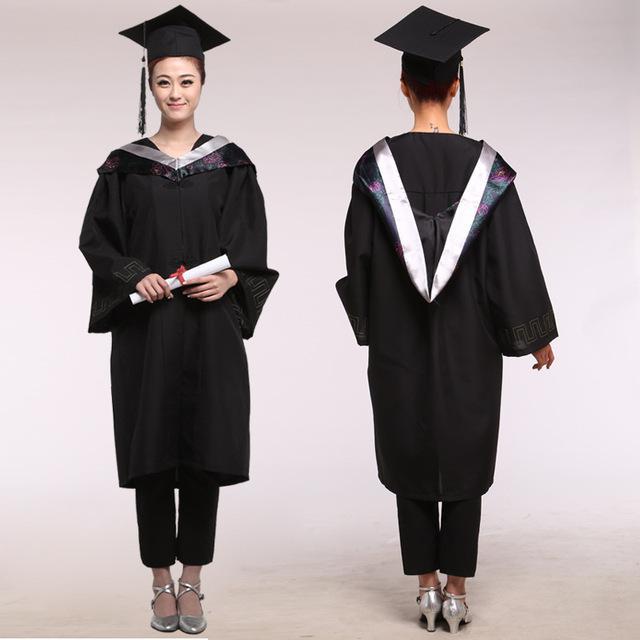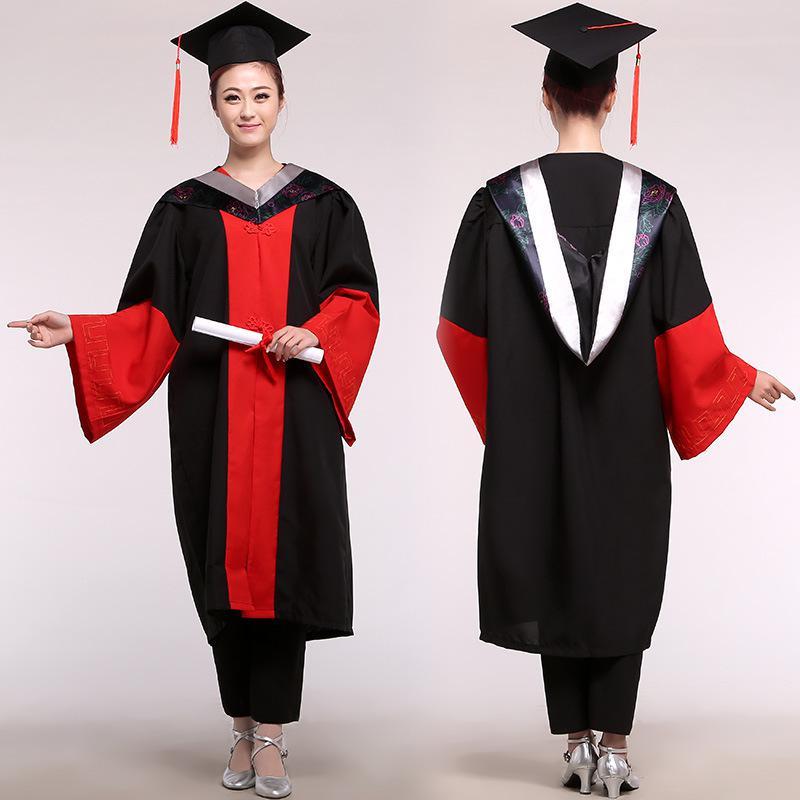The first image is the image on the left, the second image is the image on the right. Assess this claim about the two images: "a single little girl in a red cap and gown". Correct or not? Answer yes or no. No. The first image is the image on the left, the second image is the image on the right. Examine the images to the left and right. Is the description "The people holding diplomas are not wearing glasses." accurate? Answer yes or no. Yes. 